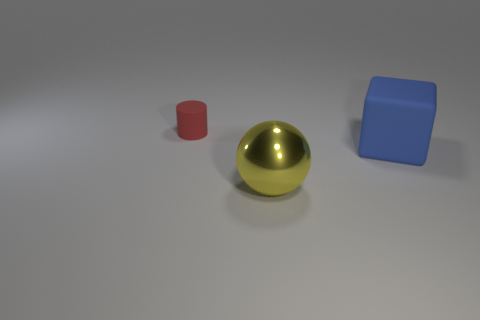Add 3 purple matte blocks. How many objects exist? 6 Subtract all cylinders. How many objects are left? 2 Add 3 tiny red matte balls. How many tiny red matte balls exist? 3 Subtract 0 blue spheres. How many objects are left? 3 Subtract all blue metal balls. Subtract all red rubber objects. How many objects are left? 2 Add 3 small things. How many small things are left? 4 